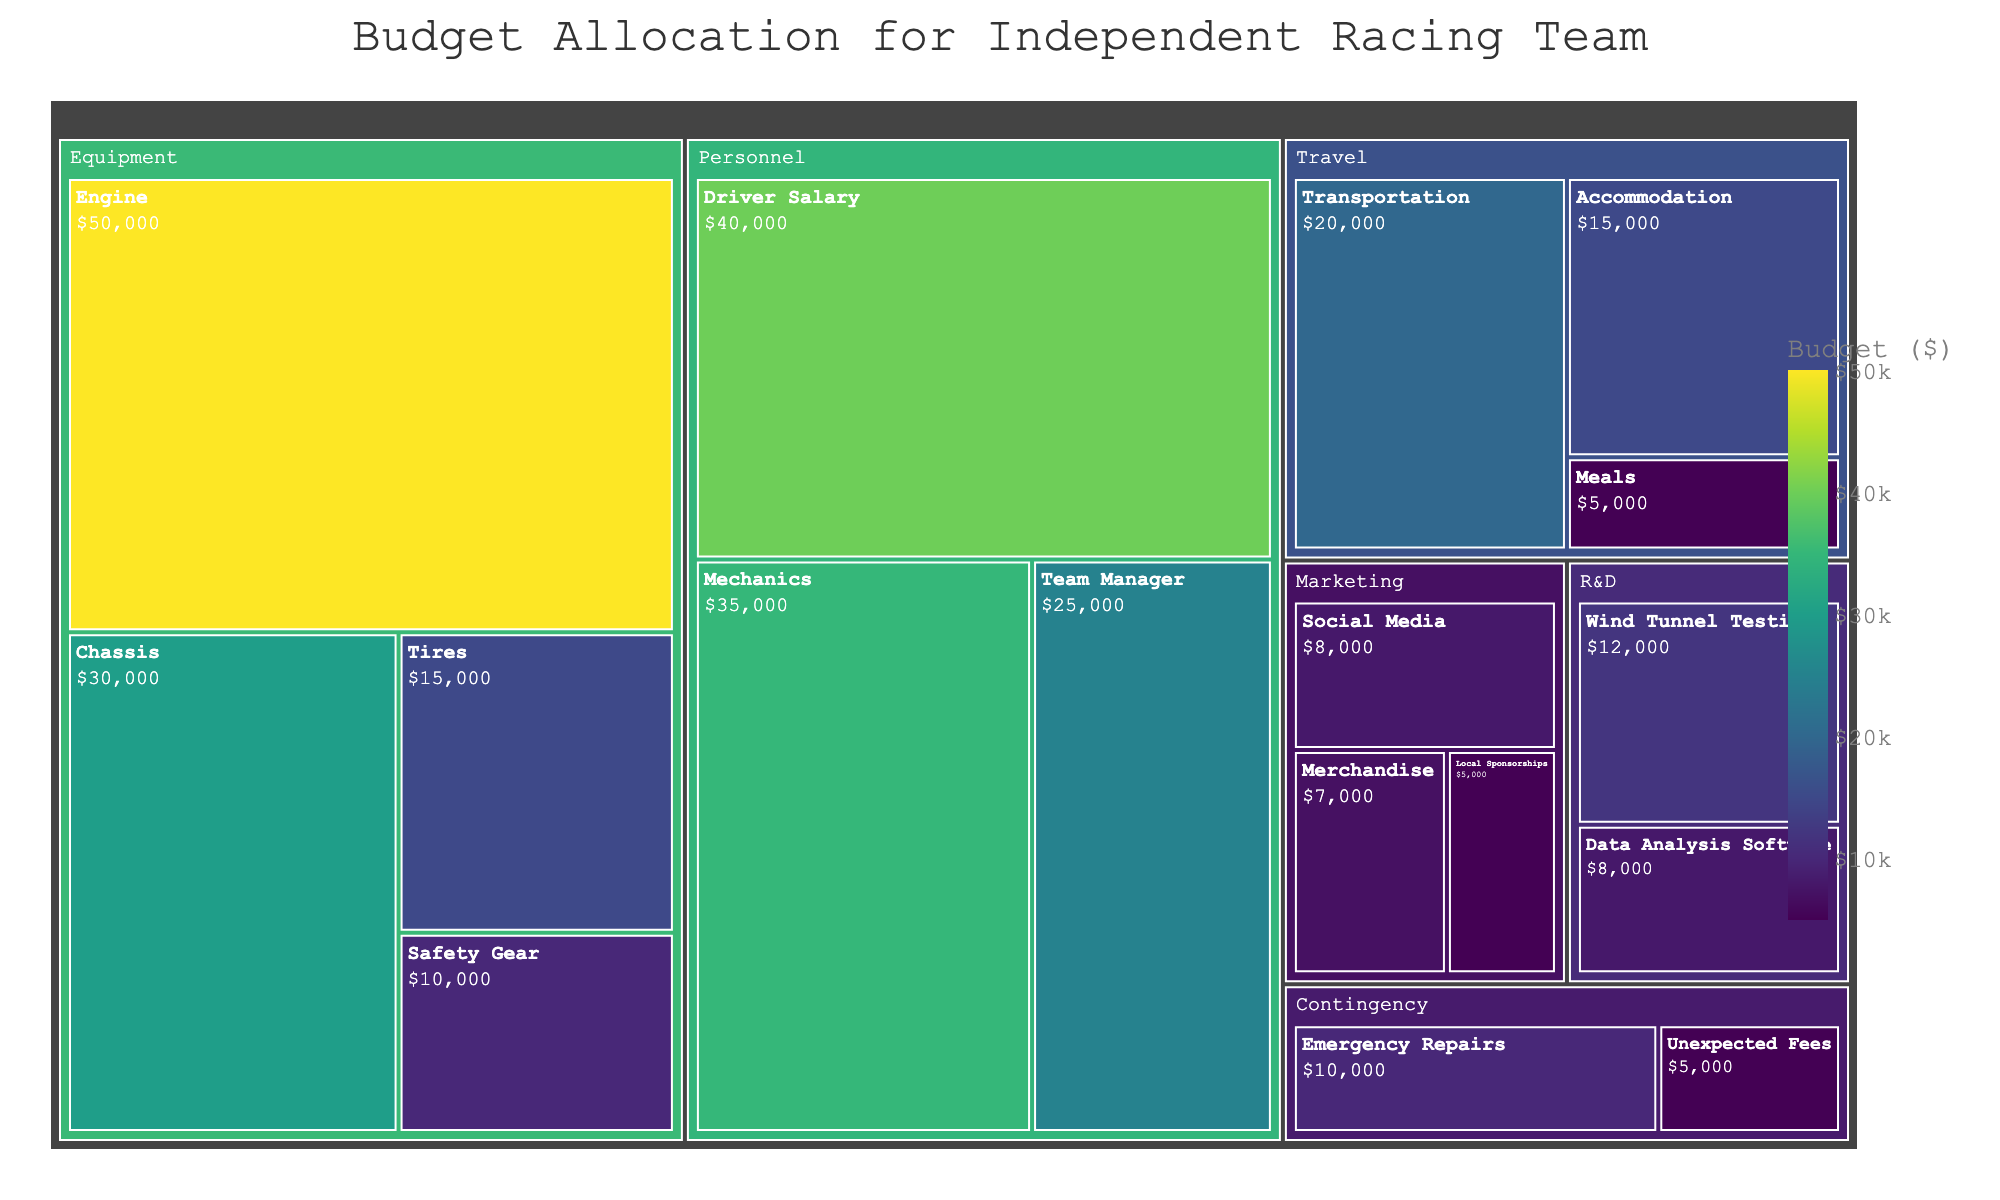How much budget was allocated to the 'Equipment' category? To find the budget allocated to the 'Equipment' category, sum up the values of all subcategories under 'Equipment': Engine ($50,000), Chassis ($30,000), Tires ($15,000), and Safety Gear ($10,000). Adding these: $50,000 + $30,000 + $15,000 + $10,000 = $105,000
Answer: $105,000 Which subcategory under 'Personnel' has the second highest budget allocation? To answer this, first identify the budgets for each subcategory under 'Personnel': Driver Salary ($40,000), Mechanics ($35,000), and Team Manager ($25,000). The second highest allocation is 'Mechanics' with $35,000
Answer: Mechanics What's the total budget for the 'Travel' and 'Marketing' categories combined? Calculate the total for 'Travel' by summing its subcategories: Transportation ($20,000), Accommodation ($15,000), Meals ($5,000) so $20,000 + $15,000 + $5,000 = $40,000. Then do the same for 'Marketing': Social Media ($8,000), Merchandise ($7,000), Local Sponsorships ($5,000) so $8,000 + $7,000 + $5,000 = $20,000. Finally, combine both totals: $40,000 + $20,000 = $60,000
Answer: $60,000 What is the smallest budget allocation among all subcategories? Reviewing the data values for all subcategories, the smallest budget allocation belongs to 'Unexpected Fees' under 'Contingency' with $5,000
Answer: $5,000 Which category has the most diverse range of subcategory budgets? To determine this, compare the range (difference between highest and lowest budgets) of subcategories within each main category. 'Equipment': $50,000 - $10,000 = $40,000, 'Personnel': $40,000 - $25,000 = $15,000, 'Travel': $20,000 - $5,000 = $15,000, 'Marketing': $8,000 - $5,000 = $3,000, 'R&D': $12,000 - $8,000 = $4,000, 'Contingency': $10,000 - $5,000 = $5,000. 'Equipment' has the widest range at $40,000
Answer: Equipment How does the budget for 'Wind Tunnel Testing' compare to 'Driver Salary'? The budget for 'Wind Tunnel Testing' is $12,000, and for 'Driver Salary' is $40,000. Comparing them, $12,000 is significantly less than $40,000
Answer: Less What proportion of the budget is allocated to 'R&D' relative to the total budget? Calculate the total budget ($324,000) by summing all category values. 'R&D' category has two subcategories: Wind Tunnel Testing ($12,000) and Data Analysis Software ($8,000), totaling $20,000. The proportion is calculated as $20,000 / $324,000 ≈ 0.0617 or about 6.17%
Answer: 6.17% What's the difference in budget allocation between 'Emergency Repairs' and 'Team Manager'? The budget for 'Emergency Repairs' is $10,000, and for 'Team Manager' is $25,000. The difference is $25,000 - $10,000 = $15,000
Answer: $15,000 Which subcategory has the highest budget allocation within 'Marketing'? Within the 'Marketing' category, compare the subcategory values: Social Media ($8,000), Merchandise ($7,000), Local Sponsorships ($5,000). The highest is Social Media with $8,000
Answer: Social Media 